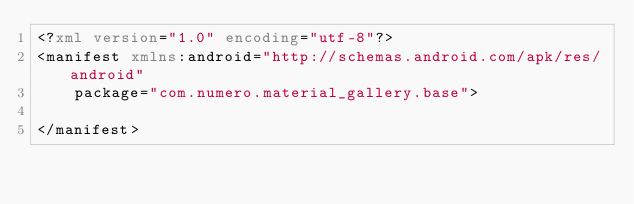Convert code to text. <code><loc_0><loc_0><loc_500><loc_500><_XML_><?xml version="1.0" encoding="utf-8"?>
<manifest xmlns:android="http://schemas.android.com/apk/res/android"
    package="com.numero.material_gallery.base">

</manifest></code> 